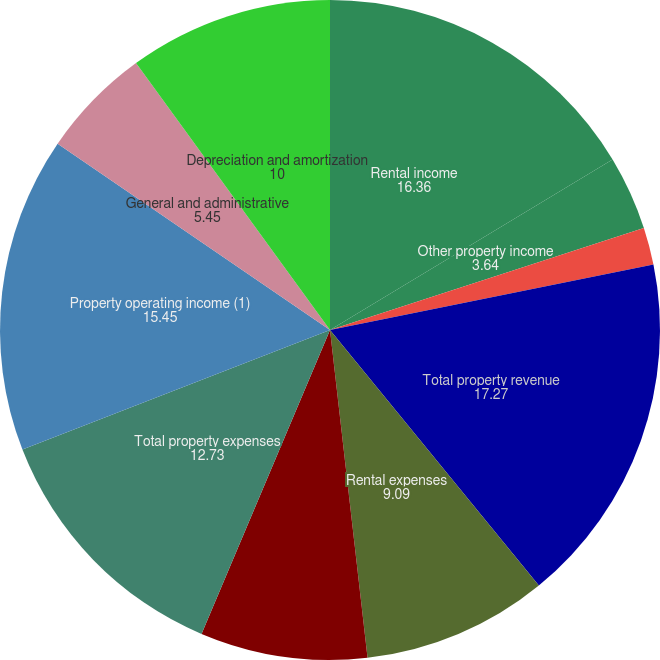Convert chart to OTSL. <chart><loc_0><loc_0><loc_500><loc_500><pie_chart><fcel>Rental income<fcel>Other property income<fcel>Mortgage interest income<fcel>Total property revenue<fcel>Rental expenses<fcel>Real estate taxes<fcel>Total property expenses<fcel>Property operating income (1)<fcel>General and administrative<fcel>Depreciation and amortization<nl><fcel>16.36%<fcel>3.64%<fcel>1.82%<fcel>17.27%<fcel>9.09%<fcel>8.18%<fcel>12.73%<fcel>15.45%<fcel>5.45%<fcel>10.0%<nl></chart> 